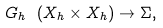Convert formula to latex. <formula><loc_0><loc_0><loc_500><loc_500>G _ { h } \ ( X _ { h } \times X _ { h } ) \rightarrow \Sigma ,</formula> 